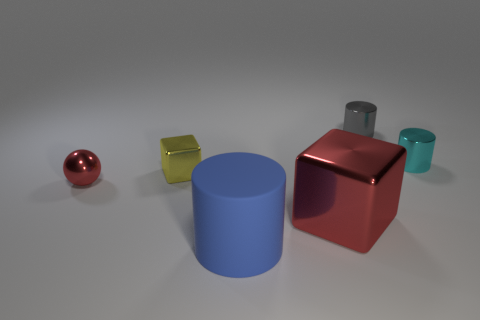Add 2 cyan shiny cylinders. How many objects exist? 8 Subtract all balls. How many objects are left? 5 Subtract all small balls. Subtract all blue matte things. How many objects are left? 4 Add 6 cyan cylinders. How many cyan cylinders are left? 7 Add 1 red metal cylinders. How many red metal cylinders exist? 1 Subtract 0 green blocks. How many objects are left? 6 